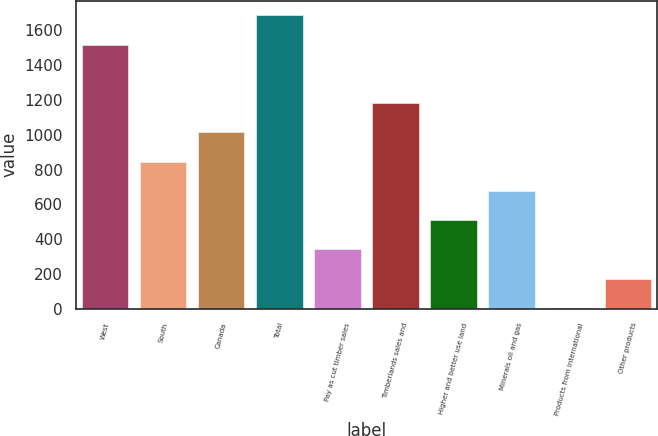Convert chart to OTSL. <chart><loc_0><loc_0><loc_500><loc_500><bar_chart><fcel>West<fcel>South<fcel>Canada<fcel>Total<fcel>Pay as cut timber sales<fcel>Timberlands sales and<fcel>Higher and better use land<fcel>Minerals oil and gas<fcel>Products from international<fcel>Other products<nl><fcel>1518<fcel>846<fcel>1014<fcel>1686<fcel>342<fcel>1182<fcel>510<fcel>678<fcel>6<fcel>174<nl></chart> 